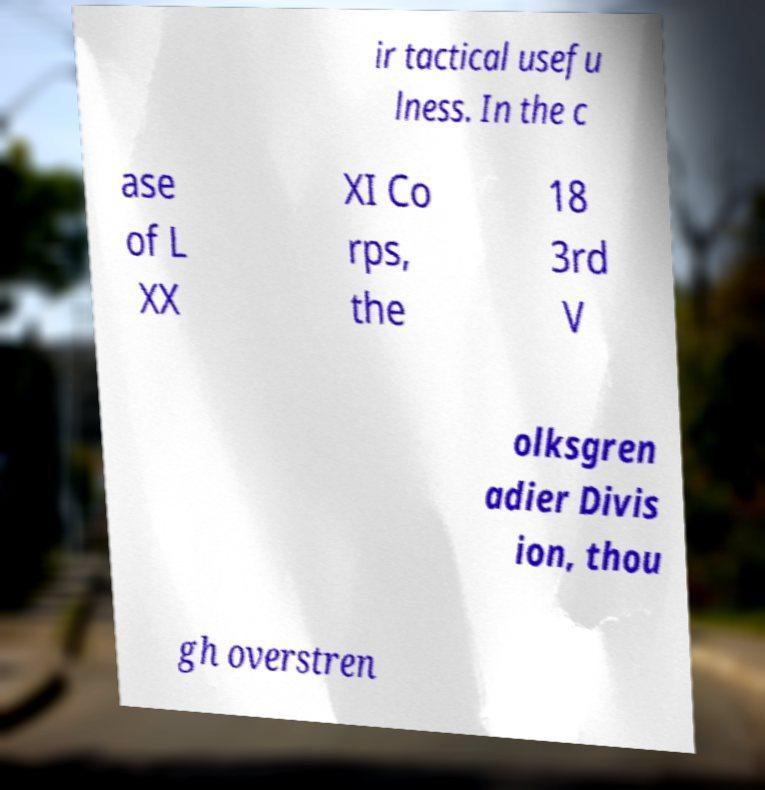For documentation purposes, I need the text within this image transcribed. Could you provide that? ir tactical usefu lness. In the c ase of L XX XI Co rps, the 18 3rd V olksgren adier Divis ion, thou gh overstren 